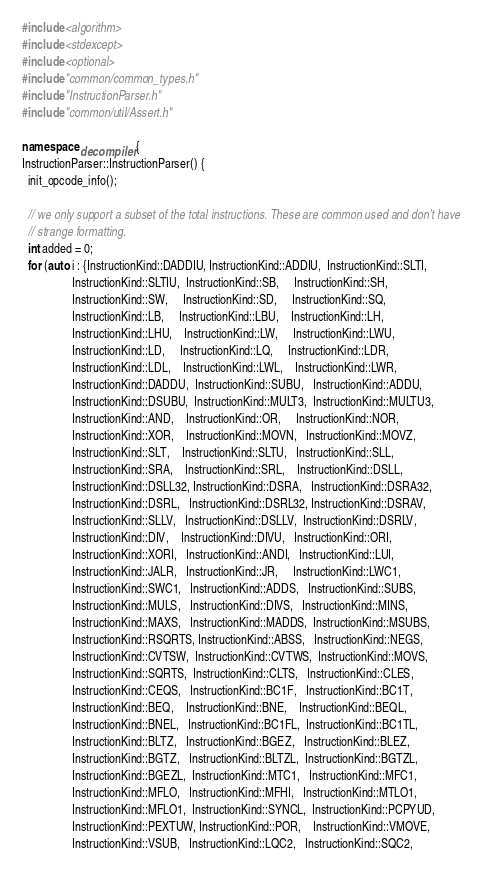<code> <loc_0><loc_0><loc_500><loc_500><_C++_>#include <algorithm>
#include <stdexcept>
#include <optional>
#include "common/common_types.h"
#include "InstructionParser.h"
#include "common/util/Assert.h"

namespace decompiler {
InstructionParser::InstructionParser() {
  init_opcode_info();

  // we only support a subset of the total instructions. These are common used and don't have
  // strange formatting.
  int added = 0;
  for (auto i : {InstructionKind::DADDIU, InstructionKind::ADDIU,  InstructionKind::SLTI,
                 InstructionKind::SLTIU,  InstructionKind::SB,     InstructionKind::SH,
                 InstructionKind::SW,     InstructionKind::SD,     InstructionKind::SQ,
                 InstructionKind::LB,     InstructionKind::LBU,    InstructionKind::LH,
                 InstructionKind::LHU,    InstructionKind::LW,     InstructionKind::LWU,
                 InstructionKind::LD,     InstructionKind::LQ,     InstructionKind::LDR,
                 InstructionKind::LDL,    InstructionKind::LWL,    InstructionKind::LWR,
                 InstructionKind::DADDU,  InstructionKind::SUBU,   InstructionKind::ADDU,
                 InstructionKind::DSUBU,  InstructionKind::MULT3,  InstructionKind::MULTU3,
                 InstructionKind::AND,    InstructionKind::OR,     InstructionKind::NOR,
                 InstructionKind::XOR,    InstructionKind::MOVN,   InstructionKind::MOVZ,
                 InstructionKind::SLT,    InstructionKind::SLTU,   InstructionKind::SLL,
                 InstructionKind::SRA,    InstructionKind::SRL,    InstructionKind::DSLL,
                 InstructionKind::DSLL32, InstructionKind::DSRA,   InstructionKind::DSRA32,
                 InstructionKind::DSRL,   InstructionKind::DSRL32, InstructionKind::DSRAV,
                 InstructionKind::SLLV,   InstructionKind::DSLLV,  InstructionKind::DSRLV,
                 InstructionKind::DIV,    InstructionKind::DIVU,   InstructionKind::ORI,
                 InstructionKind::XORI,   InstructionKind::ANDI,   InstructionKind::LUI,
                 InstructionKind::JALR,   InstructionKind::JR,     InstructionKind::LWC1,
                 InstructionKind::SWC1,   InstructionKind::ADDS,   InstructionKind::SUBS,
                 InstructionKind::MULS,   InstructionKind::DIVS,   InstructionKind::MINS,
                 InstructionKind::MAXS,   InstructionKind::MADDS,  InstructionKind::MSUBS,
                 InstructionKind::RSQRTS, InstructionKind::ABSS,   InstructionKind::NEGS,
                 InstructionKind::CVTSW,  InstructionKind::CVTWS,  InstructionKind::MOVS,
                 InstructionKind::SQRTS,  InstructionKind::CLTS,   InstructionKind::CLES,
                 InstructionKind::CEQS,   InstructionKind::BC1F,   InstructionKind::BC1T,
                 InstructionKind::BEQ,    InstructionKind::BNE,    InstructionKind::BEQL,
                 InstructionKind::BNEL,   InstructionKind::BC1FL,  InstructionKind::BC1TL,
                 InstructionKind::BLTZ,   InstructionKind::BGEZ,   InstructionKind::BLEZ,
                 InstructionKind::BGTZ,   InstructionKind::BLTZL,  InstructionKind::BGTZL,
                 InstructionKind::BGEZL,  InstructionKind::MTC1,   InstructionKind::MFC1,
                 InstructionKind::MFLO,   InstructionKind::MFHI,   InstructionKind::MTLO1,
                 InstructionKind::MFLO1,  InstructionKind::SYNCL,  InstructionKind::PCPYUD,
                 InstructionKind::PEXTUW, InstructionKind::POR,    InstructionKind::VMOVE,
                 InstructionKind::VSUB,   InstructionKind::LQC2,   InstructionKind::SQC2,</code> 